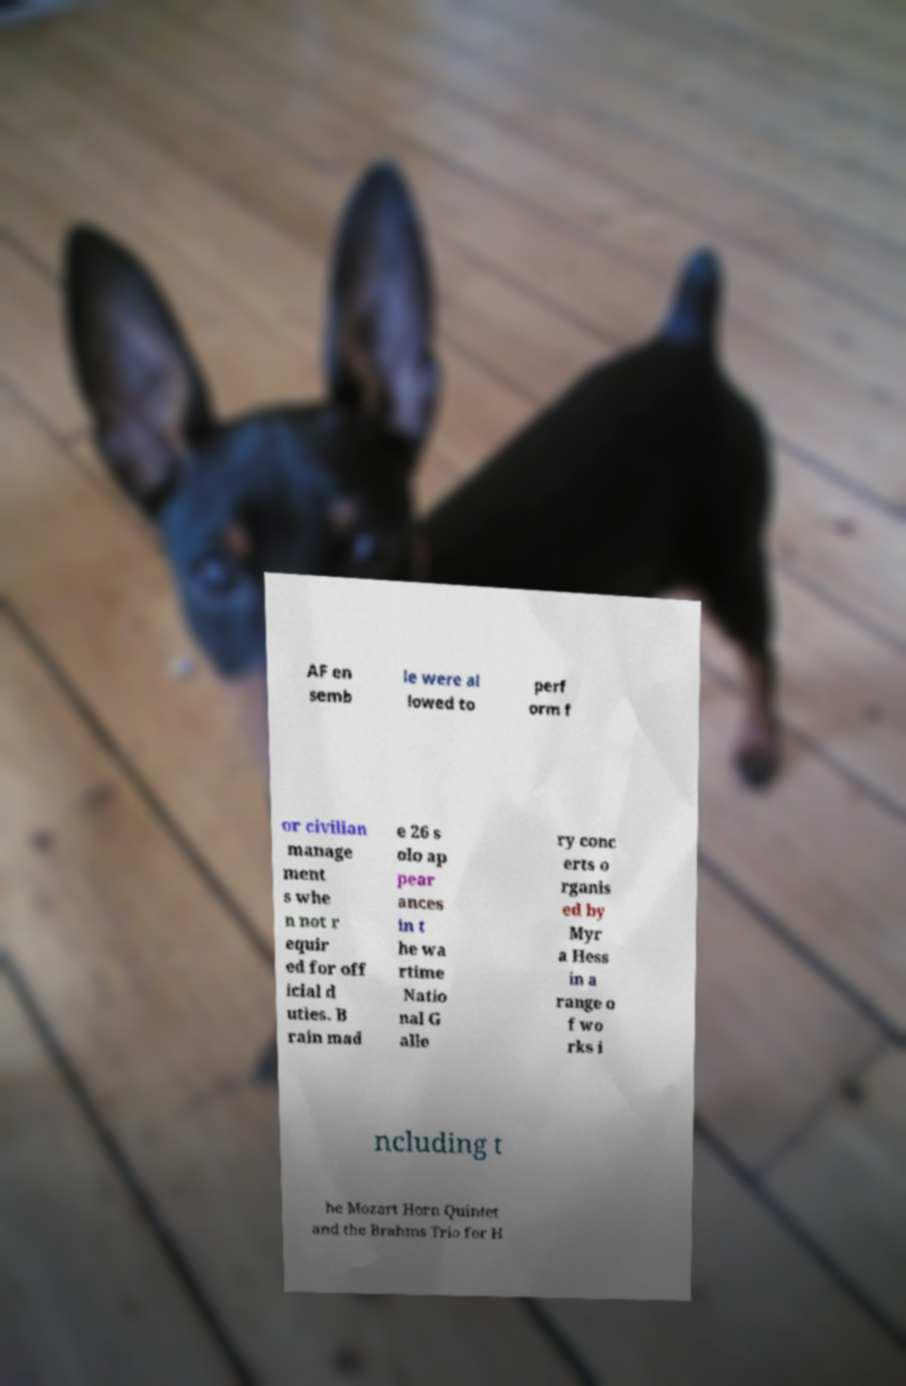For documentation purposes, I need the text within this image transcribed. Could you provide that? AF en semb le were al lowed to perf orm f or civilian manage ment s whe n not r equir ed for off icial d uties. B rain mad e 26 s olo ap pear ances in t he wa rtime Natio nal G alle ry conc erts o rganis ed by Myr a Hess in a range o f wo rks i ncluding t he Mozart Horn Quintet and the Brahms Trio for H 